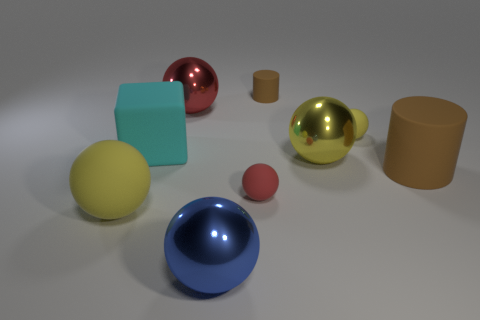Subtract all brown cubes. How many yellow balls are left? 3 Subtract 1 balls. How many balls are left? 5 Subtract all blue spheres. How many spheres are left? 5 Subtract all blue balls. How many balls are left? 5 Subtract all blue balls. Subtract all blue blocks. How many balls are left? 5 Add 1 big red metallic balls. How many objects exist? 10 Subtract all balls. How many objects are left? 3 Add 6 cubes. How many cubes are left? 7 Add 3 purple matte spheres. How many purple matte spheres exist? 3 Subtract 0 cyan cylinders. How many objects are left? 9 